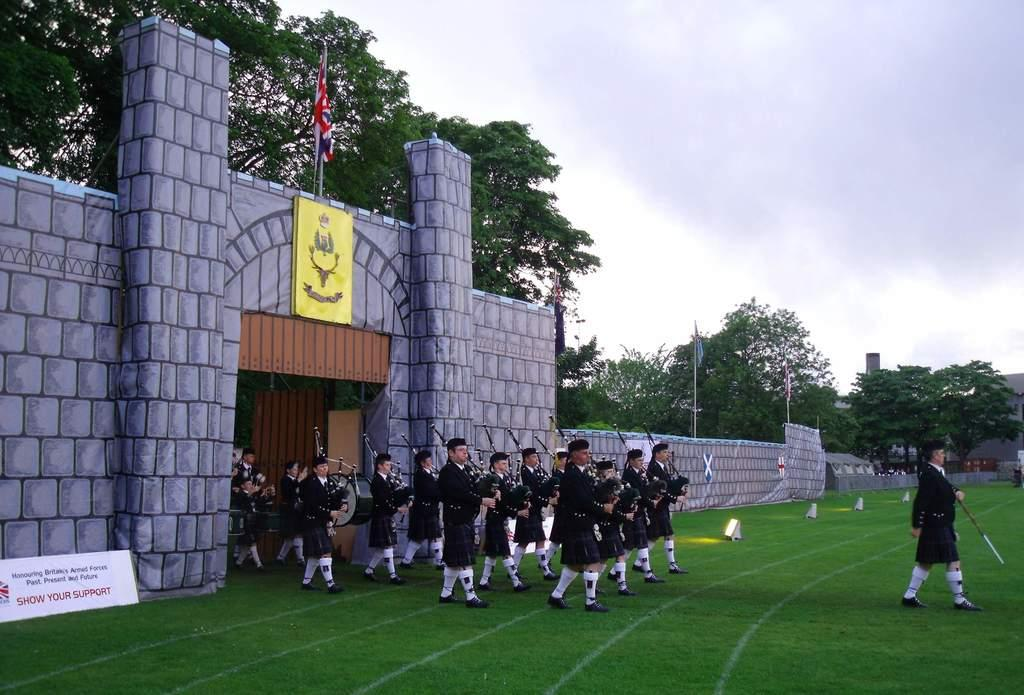Provide a one-sentence caption for the provided image. A group of Scottish band members are marching onto a field by a sign that says Show Your Support. 